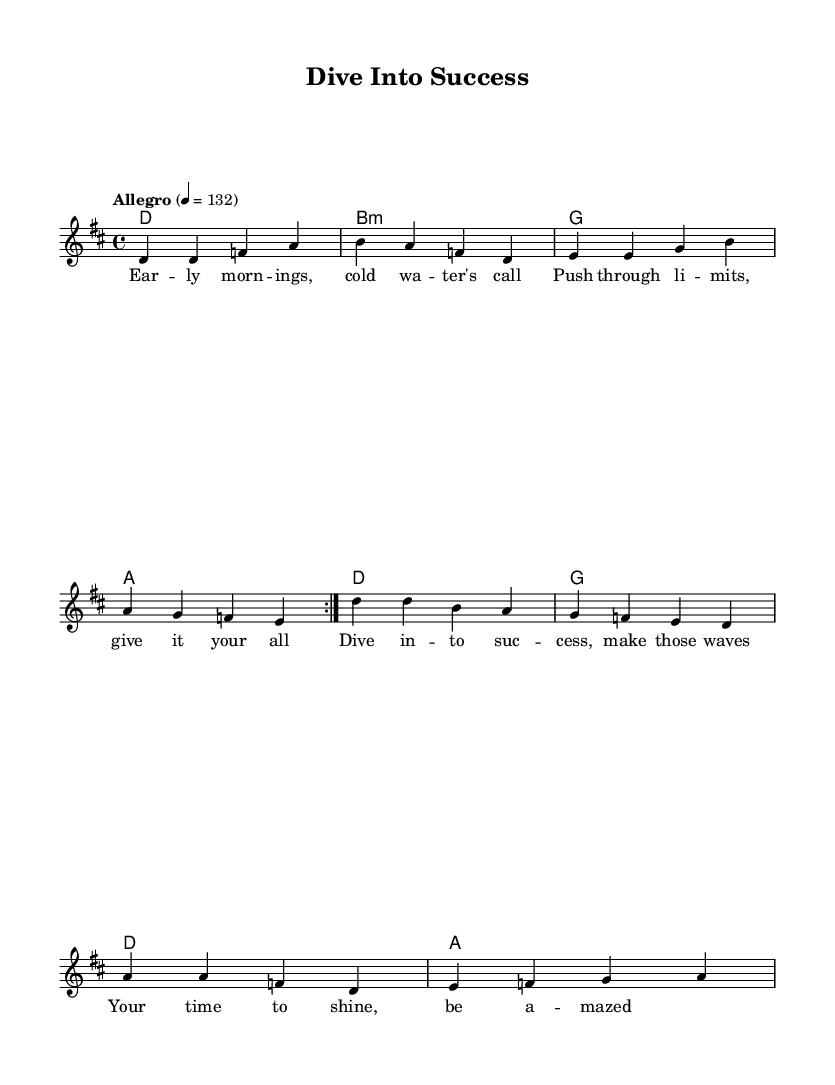What is the key signature of this music? The key signature is indicated by the sharp sign shown at the beginning of the staff. In this case, it corresponds to D major, which has two sharps (F# and C#).
Answer: D major What is the time signature of this music? The time signature is displayed at the beginning of the sheet music, represented by 4/4, meaning there are four beats per measure with a quarter note receiving one beat.
Answer: 4/4 What is the tempo marking of this music? The tempo marking is indicated within the score, stating "Allegro" and a metronome marking of 132, which denotes a fast tempo.
Answer: 132 How many measures are in the melody section? The melody section features two repeats of the primary melody. Upon analyzing the measures, we find a total of 12 distinct measures in this section.
Answer: 12 What is the first line of the lyrics? The first line of the lyrics is located at the beginning of the lyric section, aligning with the melody notes, which reads "Early mornings, cold water's call".
Answer: Early mornings, cold water's call What chords are repeated in the chorus section? The chorus section aligns chords with lyrics, and upon examining the harmony part beneath the melody, it reflects alternating between D, G, and A chords throughout the chorus.
Answer: D, G, A 